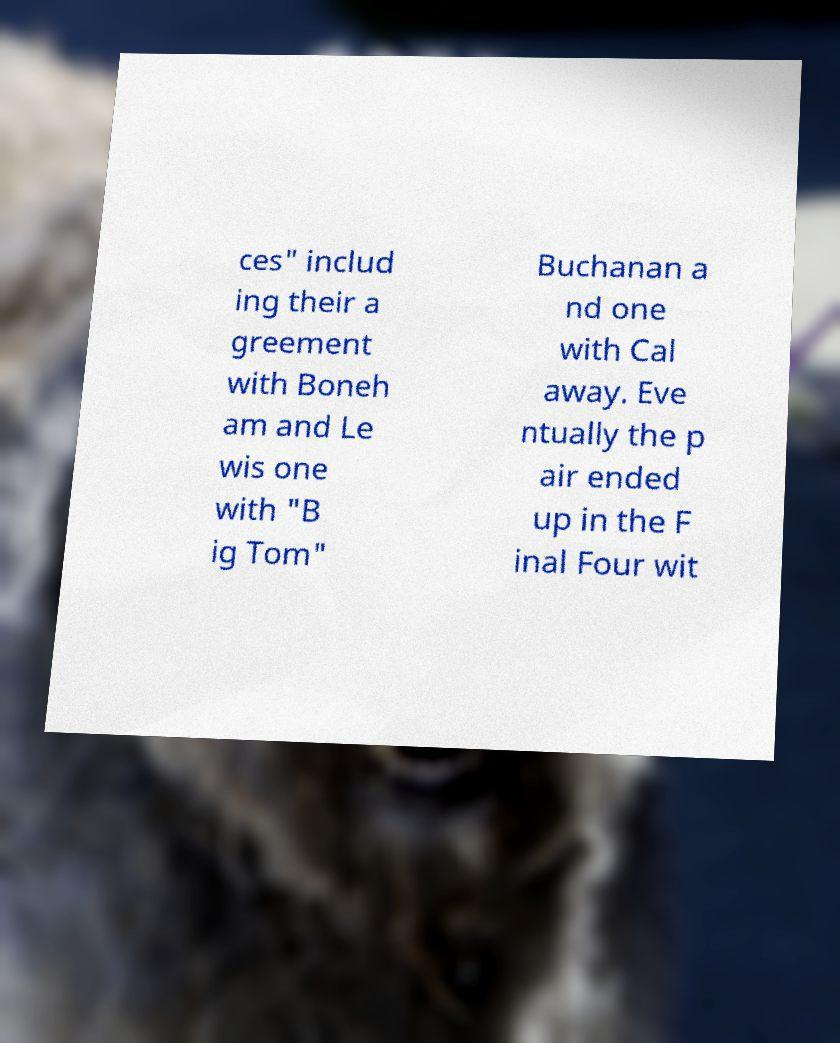Could you assist in decoding the text presented in this image and type it out clearly? ces" includ ing their a greement with Boneh am and Le wis one with "B ig Tom" Buchanan a nd one with Cal away. Eve ntually the p air ended up in the F inal Four wit 